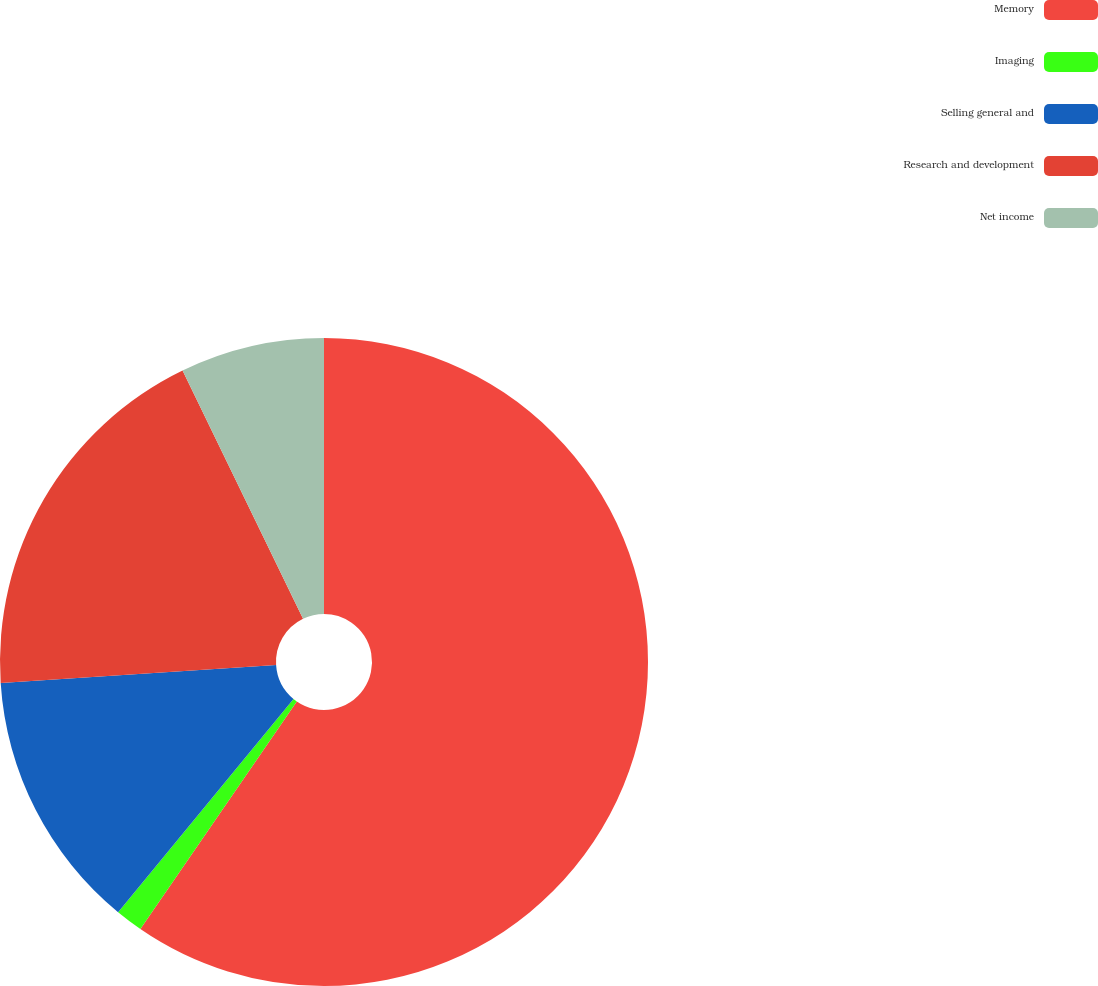<chart> <loc_0><loc_0><loc_500><loc_500><pie_chart><fcel>Memory<fcel>Imaging<fcel>Selling general and<fcel>Research and development<fcel>Net income<nl><fcel>59.59%<fcel>1.37%<fcel>13.01%<fcel>18.84%<fcel>7.19%<nl></chart> 